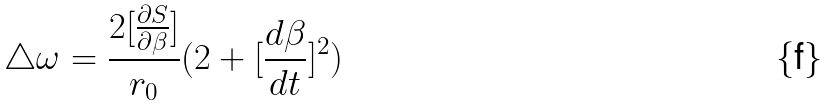Convert formula to latex. <formula><loc_0><loc_0><loc_500><loc_500>\bigtriangleup \omega = \frac { 2 [ \frac { \partial S } { \partial \beta } ] } { r _ { 0 } } ( 2 + [ \frac { d \beta } { d t } ] ^ { 2 } )</formula> 